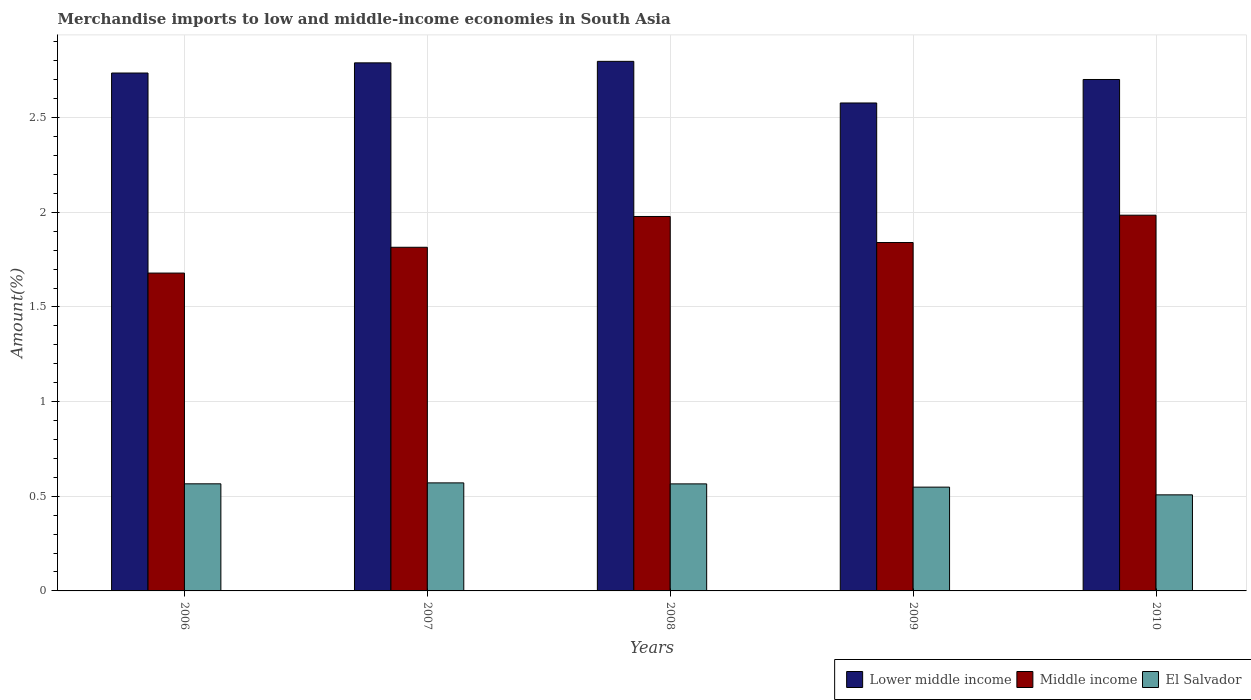What is the label of the 1st group of bars from the left?
Keep it short and to the point. 2006. In how many cases, is the number of bars for a given year not equal to the number of legend labels?
Your answer should be compact. 0. What is the percentage of amount earned from merchandise imports in Lower middle income in 2008?
Provide a short and direct response. 2.8. Across all years, what is the maximum percentage of amount earned from merchandise imports in Lower middle income?
Provide a short and direct response. 2.8. Across all years, what is the minimum percentage of amount earned from merchandise imports in Lower middle income?
Offer a very short reply. 2.58. In which year was the percentage of amount earned from merchandise imports in El Salvador minimum?
Make the answer very short. 2010. What is the total percentage of amount earned from merchandise imports in Middle income in the graph?
Provide a short and direct response. 9.3. What is the difference between the percentage of amount earned from merchandise imports in Lower middle income in 2007 and that in 2008?
Ensure brevity in your answer.  -0.01. What is the difference between the percentage of amount earned from merchandise imports in Middle income in 2009 and the percentage of amount earned from merchandise imports in Lower middle income in 2006?
Make the answer very short. -0.9. What is the average percentage of amount earned from merchandise imports in El Salvador per year?
Ensure brevity in your answer.  0.55. In the year 2006, what is the difference between the percentage of amount earned from merchandise imports in Lower middle income and percentage of amount earned from merchandise imports in Middle income?
Provide a succinct answer. 1.06. In how many years, is the percentage of amount earned from merchandise imports in El Salvador greater than 2.6 %?
Give a very brief answer. 0. What is the ratio of the percentage of amount earned from merchandise imports in Middle income in 2006 to that in 2010?
Your response must be concise. 0.85. Is the percentage of amount earned from merchandise imports in El Salvador in 2006 less than that in 2008?
Provide a short and direct response. No. What is the difference between the highest and the second highest percentage of amount earned from merchandise imports in Lower middle income?
Your response must be concise. 0.01. What is the difference between the highest and the lowest percentage of amount earned from merchandise imports in Lower middle income?
Offer a terse response. 0.22. In how many years, is the percentage of amount earned from merchandise imports in Middle income greater than the average percentage of amount earned from merchandise imports in Middle income taken over all years?
Ensure brevity in your answer.  2. What does the 3rd bar from the left in 2008 represents?
Provide a succinct answer. El Salvador. What does the 1st bar from the right in 2010 represents?
Make the answer very short. El Salvador. Does the graph contain any zero values?
Provide a succinct answer. No. Where does the legend appear in the graph?
Give a very brief answer. Bottom right. How many legend labels are there?
Provide a short and direct response. 3. What is the title of the graph?
Give a very brief answer. Merchandise imports to low and middle-income economies in South Asia. Does "Mongolia" appear as one of the legend labels in the graph?
Ensure brevity in your answer.  No. What is the label or title of the X-axis?
Ensure brevity in your answer.  Years. What is the label or title of the Y-axis?
Give a very brief answer. Amount(%). What is the Amount(%) of Lower middle income in 2006?
Ensure brevity in your answer.  2.74. What is the Amount(%) in Middle income in 2006?
Offer a very short reply. 1.68. What is the Amount(%) in El Salvador in 2006?
Provide a short and direct response. 0.57. What is the Amount(%) in Lower middle income in 2007?
Your response must be concise. 2.79. What is the Amount(%) of Middle income in 2007?
Provide a short and direct response. 1.82. What is the Amount(%) of El Salvador in 2007?
Offer a terse response. 0.57. What is the Amount(%) in Lower middle income in 2008?
Make the answer very short. 2.8. What is the Amount(%) in Middle income in 2008?
Give a very brief answer. 1.98. What is the Amount(%) of El Salvador in 2008?
Offer a terse response. 0.57. What is the Amount(%) of Lower middle income in 2009?
Offer a terse response. 2.58. What is the Amount(%) in Middle income in 2009?
Provide a succinct answer. 1.84. What is the Amount(%) in El Salvador in 2009?
Provide a short and direct response. 0.55. What is the Amount(%) in Lower middle income in 2010?
Provide a short and direct response. 2.7. What is the Amount(%) of Middle income in 2010?
Ensure brevity in your answer.  1.98. What is the Amount(%) of El Salvador in 2010?
Make the answer very short. 0.51. Across all years, what is the maximum Amount(%) of Lower middle income?
Offer a terse response. 2.8. Across all years, what is the maximum Amount(%) of Middle income?
Provide a short and direct response. 1.98. Across all years, what is the maximum Amount(%) of El Salvador?
Ensure brevity in your answer.  0.57. Across all years, what is the minimum Amount(%) of Lower middle income?
Ensure brevity in your answer.  2.58. Across all years, what is the minimum Amount(%) of Middle income?
Ensure brevity in your answer.  1.68. Across all years, what is the minimum Amount(%) of El Salvador?
Make the answer very short. 0.51. What is the total Amount(%) in Lower middle income in the graph?
Keep it short and to the point. 13.6. What is the total Amount(%) of Middle income in the graph?
Keep it short and to the point. 9.3. What is the total Amount(%) in El Salvador in the graph?
Provide a short and direct response. 2.76. What is the difference between the Amount(%) in Lower middle income in 2006 and that in 2007?
Provide a succinct answer. -0.05. What is the difference between the Amount(%) in Middle income in 2006 and that in 2007?
Offer a terse response. -0.14. What is the difference between the Amount(%) in El Salvador in 2006 and that in 2007?
Offer a very short reply. -0.01. What is the difference between the Amount(%) of Lower middle income in 2006 and that in 2008?
Offer a very short reply. -0.06. What is the difference between the Amount(%) of Middle income in 2006 and that in 2008?
Provide a succinct answer. -0.3. What is the difference between the Amount(%) of Lower middle income in 2006 and that in 2009?
Offer a very short reply. 0.16. What is the difference between the Amount(%) of Middle income in 2006 and that in 2009?
Keep it short and to the point. -0.16. What is the difference between the Amount(%) in El Salvador in 2006 and that in 2009?
Offer a very short reply. 0.02. What is the difference between the Amount(%) of Lower middle income in 2006 and that in 2010?
Provide a short and direct response. 0.03. What is the difference between the Amount(%) in Middle income in 2006 and that in 2010?
Provide a succinct answer. -0.31. What is the difference between the Amount(%) in El Salvador in 2006 and that in 2010?
Your answer should be compact. 0.06. What is the difference between the Amount(%) of Lower middle income in 2007 and that in 2008?
Give a very brief answer. -0.01. What is the difference between the Amount(%) in Middle income in 2007 and that in 2008?
Your response must be concise. -0.16. What is the difference between the Amount(%) of El Salvador in 2007 and that in 2008?
Keep it short and to the point. 0.01. What is the difference between the Amount(%) in Lower middle income in 2007 and that in 2009?
Keep it short and to the point. 0.21. What is the difference between the Amount(%) in Middle income in 2007 and that in 2009?
Offer a terse response. -0.03. What is the difference between the Amount(%) of El Salvador in 2007 and that in 2009?
Offer a terse response. 0.02. What is the difference between the Amount(%) in Lower middle income in 2007 and that in 2010?
Offer a very short reply. 0.09. What is the difference between the Amount(%) of Middle income in 2007 and that in 2010?
Provide a succinct answer. -0.17. What is the difference between the Amount(%) of El Salvador in 2007 and that in 2010?
Keep it short and to the point. 0.06. What is the difference between the Amount(%) in Lower middle income in 2008 and that in 2009?
Make the answer very short. 0.22. What is the difference between the Amount(%) in Middle income in 2008 and that in 2009?
Make the answer very short. 0.14. What is the difference between the Amount(%) in El Salvador in 2008 and that in 2009?
Ensure brevity in your answer.  0.02. What is the difference between the Amount(%) in Lower middle income in 2008 and that in 2010?
Provide a short and direct response. 0.1. What is the difference between the Amount(%) in Middle income in 2008 and that in 2010?
Provide a short and direct response. -0.01. What is the difference between the Amount(%) of El Salvador in 2008 and that in 2010?
Keep it short and to the point. 0.06. What is the difference between the Amount(%) in Lower middle income in 2009 and that in 2010?
Ensure brevity in your answer.  -0.12. What is the difference between the Amount(%) of Middle income in 2009 and that in 2010?
Your response must be concise. -0.14. What is the difference between the Amount(%) of El Salvador in 2009 and that in 2010?
Offer a very short reply. 0.04. What is the difference between the Amount(%) of Lower middle income in 2006 and the Amount(%) of Middle income in 2007?
Offer a very short reply. 0.92. What is the difference between the Amount(%) of Lower middle income in 2006 and the Amount(%) of El Salvador in 2007?
Ensure brevity in your answer.  2.17. What is the difference between the Amount(%) of Middle income in 2006 and the Amount(%) of El Salvador in 2007?
Provide a short and direct response. 1.11. What is the difference between the Amount(%) in Lower middle income in 2006 and the Amount(%) in Middle income in 2008?
Provide a succinct answer. 0.76. What is the difference between the Amount(%) in Lower middle income in 2006 and the Amount(%) in El Salvador in 2008?
Offer a very short reply. 2.17. What is the difference between the Amount(%) in Middle income in 2006 and the Amount(%) in El Salvador in 2008?
Ensure brevity in your answer.  1.11. What is the difference between the Amount(%) of Lower middle income in 2006 and the Amount(%) of Middle income in 2009?
Your answer should be compact. 0.9. What is the difference between the Amount(%) in Lower middle income in 2006 and the Amount(%) in El Salvador in 2009?
Provide a short and direct response. 2.19. What is the difference between the Amount(%) of Middle income in 2006 and the Amount(%) of El Salvador in 2009?
Keep it short and to the point. 1.13. What is the difference between the Amount(%) of Lower middle income in 2006 and the Amount(%) of Middle income in 2010?
Provide a short and direct response. 0.75. What is the difference between the Amount(%) in Lower middle income in 2006 and the Amount(%) in El Salvador in 2010?
Your answer should be compact. 2.23. What is the difference between the Amount(%) of Middle income in 2006 and the Amount(%) of El Salvador in 2010?
Your answer should be very brief. 1.17. What is the difference between the Amount(%) of Lower middle income in 2007 and the Amount(%) of Middle income in 2008?
Provide a succinct answer. 0.81. What is the difference between the Amount(%) in Lower middle income in 2007 and the Amount(%) in El Salvador in 2008?
Offer a very short reply. 2.22. What is the difference between the Amount(%) of Middle income in 2007 and the Amount(%) of El Salvador in 2008?
Give a very brief answer. 1.25. What is the difference between the Amount(%) in Lower middle income in 2007 and the Amount(%) in Middle income in 2009?
Your answer should be compact. 0.95. What is the difference between the Amount(%) in Lower middle income in 2007 and the Amount(%) in El Salvador in 2009?
Keep it short and to the point. 2.24. What is the difference between the Amount(%) in Middle income in 2007 and the Amount(%) in El Salvador in 2009?
Offer a very short reply. 1.27. What is the difference between the Amount(%) of Lower middle income in 2007 and the Amount(%) of Middle income in 2010?
Provide a succinct answer. 0.8. What is the difference between the Amount(%) of Lower middle income in 2007 and the Amount(%) of El Salvador in 2010?
Give a very brief answer. 2.28. What is the difference between the Amount(%) in Middle income in 2007 and the Amount(%) in El Salvador in 2010?
Provide a short and direct response. 1.31. What is the difference between the Amount(%) of Lower middle income in 2008 and the Amount(%) of El Salvador in 2009?
Provide a short and direct response. 2.25. What is the difference between the Amount(%) of Middle income in 2008 and the Amount(%) of El Salvador in 2009?
Ensure brevity in your answer.  1.43. What is the difference between the Amount(%) of Lower middle income in 2008 and the Amount(%) of Middle income in 2010?
Give a very brief answer. 0.81. What is the difference between the Amount(%) of Lower middle income in 2008 and the Amount(%) of El Salvador in 2010?
Ensure brevity in your answer.  2.29. What is the difference between the Amount(%) of Middle income in 2008 and the Amount(%) of El Salvador in 2010?
Offer a terse response. 1.47. What is the difference between the Amount(%) of Lower middle income in 2009 and the Amount(%) of Middle income in 2010?
Offer a terse response. 0.59. What is the difference between the Amount(%) of Lower middle income in 2009 and the Amount(%) of El Salvador in 2010?
Ensure brevity in your answer.  2.07. What is the difference between the Amount(%) in Middle income in 2009 and the Amount(%) in El Salvador in 2010?
Ensure brevity in your answer.  1.33. What is the average Amount(%) of Lower middle income per year?
Provide a short and direct response. 2.72. What is the average Amount(%) in Middle income per year?
Your answer should be very brief. 1.86. What is the average Amount(%) in El Salvador per year?
Your answer should be very brief. 0.55. In the year 2006, what is the difference between the Amount(%) in Lower middle income and Amount(%) in Middle income?
Keep it short and to the point. 1.06. In the year 2006, what is the difference between the Amount(%) in Lower middle income and Amount(%) in El Salvador?
Ensure brevity in your answer.  2.17. In the year 2006, what is the difference between the Amount(%) of Middle income and Amount(%) of El Salvador?
Provide a succinct answer. 1.11. In the year 2007, what is the difference between the Amount(%) in Lower middle income and Amount(%) in Middle income?
Ensure brevity in your answer.  0.97. In the year 2007, what is the difference between the Amount(%) in Lower middle income and Amount(%) in El Salvador?
Ensure brevity in your answer.  2.22. In the year 2007, what is the difference between the Amount(%) of Middle income and Amount(%) of El Salvador?
Provide a short and direct response. 1.24. In the year 2008, what is the difference between the Amount(%) in Lower middle income and Amount(%) in Middle income?
Offer a terse response. 0.82. In the year 2008, what is the difference between the Amount(%) of Lower middle income and Amount(%) of El Salvador?
Keep it short and to the point. 2.23. In the year 2008, what is the difference between the Amount(%) of Middle income and Amount(%) of El Salvador?
Your answer should be compact. 1.41. In the year 2009, what is the difference between the Amount(%) of Lower middle income and Amount(%) of Middle income?
Offer a terse response. 0.74. In the year 2009, what is the difference between the Amount(%) of Lower middle income and Amount(%) of El Salvador?
Provide a short and direct response. 2.03. In the year 2009, what is the difference between the Amount(%) in Middle income and Amount(%) in El Salvador?
Give a very brief answer. 1.29. In the year 2010, what is the difference between the Amount(%) of Lower middle income and Amount(%) of Middle income?
Your response must be concise. 0.72. In the year 2010, what is the difference between the Amount(%) of Lower middle income and Amount(%) of El Salvador?
Provide a succinct answer. 2.19. In the year 2010, what is the difference between the Amount(%) of Middle income and Amount(%) of El Salvador?
Offer a terse response. 1.48. What is the ratio of the Amount(%) in Lower middle income in 2006 to that in 2007?
Give a very brief answer. 0.98. What is the ratio of the Amount(%) in Middle income in 2006 to that in 2007?
Make the answer very short. 0.92. What is the ratio of the Amount(%) in Middle income in 2006 to that in 2008?
Your answer should be very brief. 0.85. What is the ratio of the Amount(%) in Lower middle income in 2006 to that in 2009?
Provide a succinct answer. 1.06. What is the ratio of the Amount(%) in Middle income in 2006 to that in 2009?
Your response must be concise. 0.91. What is the ratio of the Amount(%) in El Salvador in 2006 to that in 2009?
Your answer should be very brief. 1.03. What is the ratio of the Amount(%) in Lower middle income in 2006 to that in 2010?
Your answer should be very brief. 1.01. What is the ratio of the Amount(%) of Middle income in 2006 to that in 2010?
Keep it short and to the point. 0.85. What is the ratio of the Amount(%) of El Salvador in 2006 to that in 2010?
Your answer should be very brief. 1.11. What is the ratio of the Amount(%) in Lower middle income in 2007 to that in 2008?
Ensure brevity in your answer.  1. What is the ratio of the Amount(%) in Middle income in 2007 to that in 2008?
Provide a short and direct response. 0.92. What is the ratio of the Amount(%) of El Salvador in 2007 to that in 2008?
Provide a succinct answer. 1.01. What is the ratio of the Amount(%) in Lower middle income in 2007 to that in 2009?
Keep it short and to the point. 1.08. What is the ratio of the Amount(%) of Middle income in 2007 to that in 2009?
Offer a very short reply. 0.99. What is the ratio of the Amount(%) in El Salvador in 2007 to that in 2009?
Make the answer very short. 1.04. What is the ratio of the Amount(%) in Lower middle income in 2007 to that in 2010?
Your answer should be very brief. 1.03. What is the ratio of the Amount(%) in Middle income in 2007 to that in 2010?
Keep it short and to the point. 0.91. What is the ratio of the Amount(%) in El Salvador in 2007 to that in 2010?
Give a very brief answer. 1.12. What is the ratio of the Amount(%) in Lower middle income in 2008 to that in 2009?
Offer a terse response. 1.09. What is the ratio of the Amount(%) in Middle income in 2008 to that in 2009?
Offer a terse response. 1.07. What is the ratio of the Amount(%) of El Salvador in 2008 to that in 2009?
Offer a terse response. 1.03. What is the ratio of the Amount(%) of Lower middle income in 2008 to that in 2010?
Provide a short and direct response. 1.04. What is the ratio of the Amount(%) of El Salvador in 2008 to that in 2010?
Ensure brevity in your answer.  1.11. What is the ratio of the Amount(%) in Lower middle income in 2009 to that in 2010?
Your response must be concise. 0.95. What is the ratio of the Amount(%) of Middle income in 2009 to that in 2010?
Give a very brief answer. 0.93. What is the ratio of the Amount(%) of El Salvador in 2009 to that in 2010?
Ensure brevity in your answer.  1.08. What is the difference between the highest and the second highest Amount(%) in Lower middle income?
Your response must be concise. 0.01. What is the difference between the highest and the second highest Amount(%) in Middle income?
Offer a terse response. 0.01. What is the difference between the highest and the second highest Amount(%) of El Salvador?
Provide a succinct answer. 0.01. What is the difference between the highest and the lowest Amount(%) of Lower middle income?
Provide a succinct answer. 0.22. What is the difference between the highest and the lowest Amount(%) in Middle income?
Offer a terse response. 0.31. What is the difference between the highest and the lowest Amount(%) of El Salvador?
Provide a short and direct response. 0.06. 